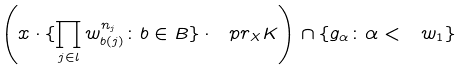<formula> <loc_0><loc_0><loc_500><loc_500>\left ( x \cdot \{ \prod _ { j \in l } w _ { b ( j ) } ^ { n _ { j } } \colon b \in B \} \cdot \ p r _ { X } K \right ) \cap \{ g _ { \alpha } \colon \alpha < \ w _ { 1 } \}</formula> 